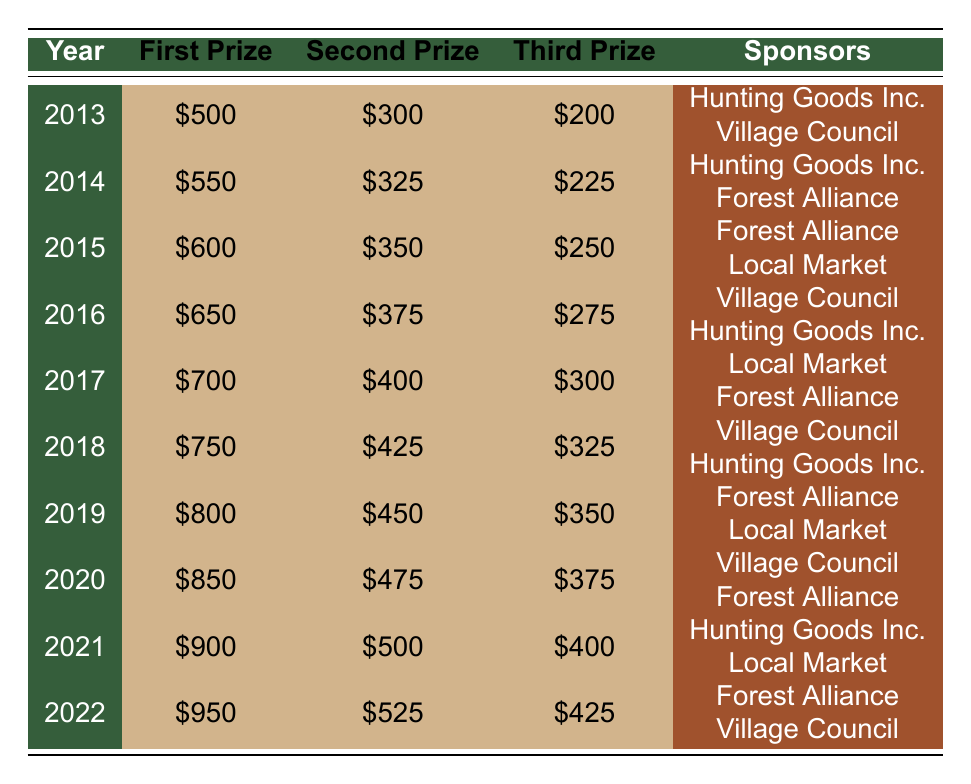What was the first prize amount in 2019? From the table, I look at the row corresponding to the year 2019. The column for the first prize shows the amount of 800.
Answer: 800 Which year had the lowest third prize? I review the third prize column for each year and find that the lowest value appears in 2013, where the third prize is 200.
Answer: 200 What was the total prize money for all three prizes in 2021? I will sum the amounts for the first, second, and third prizes in 2021: 900 (first) + 500 (second) + 400 (third) = 1800.
Answer: 1800 Did the second prize increase every year from 2013 to 2022? I check the second prize amounts from 2013 to 2022. The values are: 300, 325, 350, 375, 400, 425, 450, 475, 500, and 525. They show a consistent increase.
Answer: Yes What is the average first prize amount over the last decade? To calculate the average, I add all the first prizes from 2013 to 2022: 500 + 550 + 600 + 650 + 700 + 750 + 800 + 850 + 900 + 950 = 7550. Then I divide by 10 (the number of years): 7550 / 10 = 755.
Answer: 755 